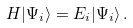<formula> <loc_0><loc_0><loc_500><loc_500>H | \Psi _ { i } \rangle = E _ { i } | \Psi _ { i } \rangle \, .</formula> 